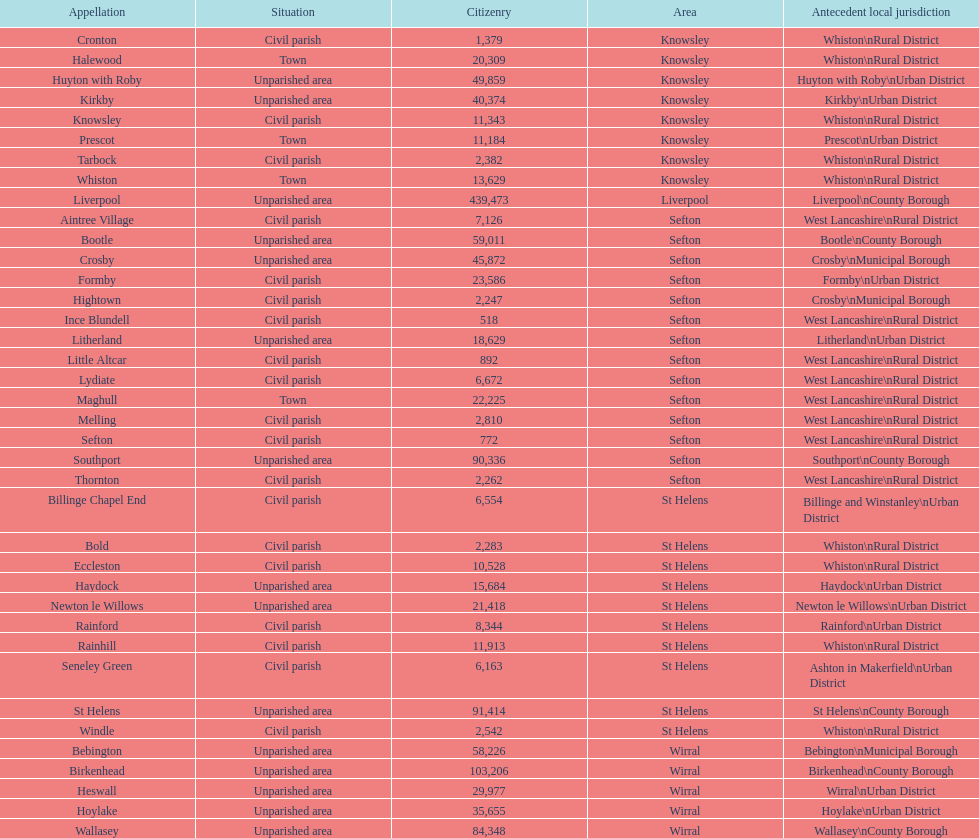Provide the quantity of people living in formby. 23,586. 